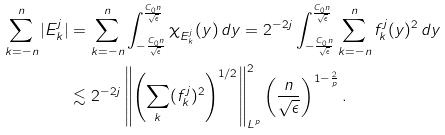Convert formula to latex. <formula><loc_0><loc_0><loc_500><loc_500>\sum _ { k = - n } ^ { n } | E ^ { j } _ { k } | & = \sum _ { k = - n } ^ { n } \int _ { - \frac { C _ { 0 } n } { \sqrt { \epsilon } } } ^ { \frac { C _ { 0 } n } { \sqrt { \epsilon } } } \chi _ { E ^ { j } _ { k } } ( y ) \, d y = 2 ^ { - 2 j } \int _ { - \frac { C _ { 0 } n } { \sqrt { \epsilon } } } ^ { \frac { C _ { 0 } n } { \sqrt { \epsilon } } } \sum _ { k = - n } ^ { n } f ^ { j } _ { k } ( y ) ^ { 2 } \, d y \\ & \lesssim 2 ^ { - 2 j } \left \| \left ( \sum _ { k } ( f _ { k } ^ { j } ) ^ { 2 } \right ) ^ { 1 / 2 } \right \| _ { L ^ { p } } ^ { 2 } \left ( \frac { n } { \sqrt { \epsilon } } \right ) ^ { 1 - \frac { 2 } { p } } .</formula> 